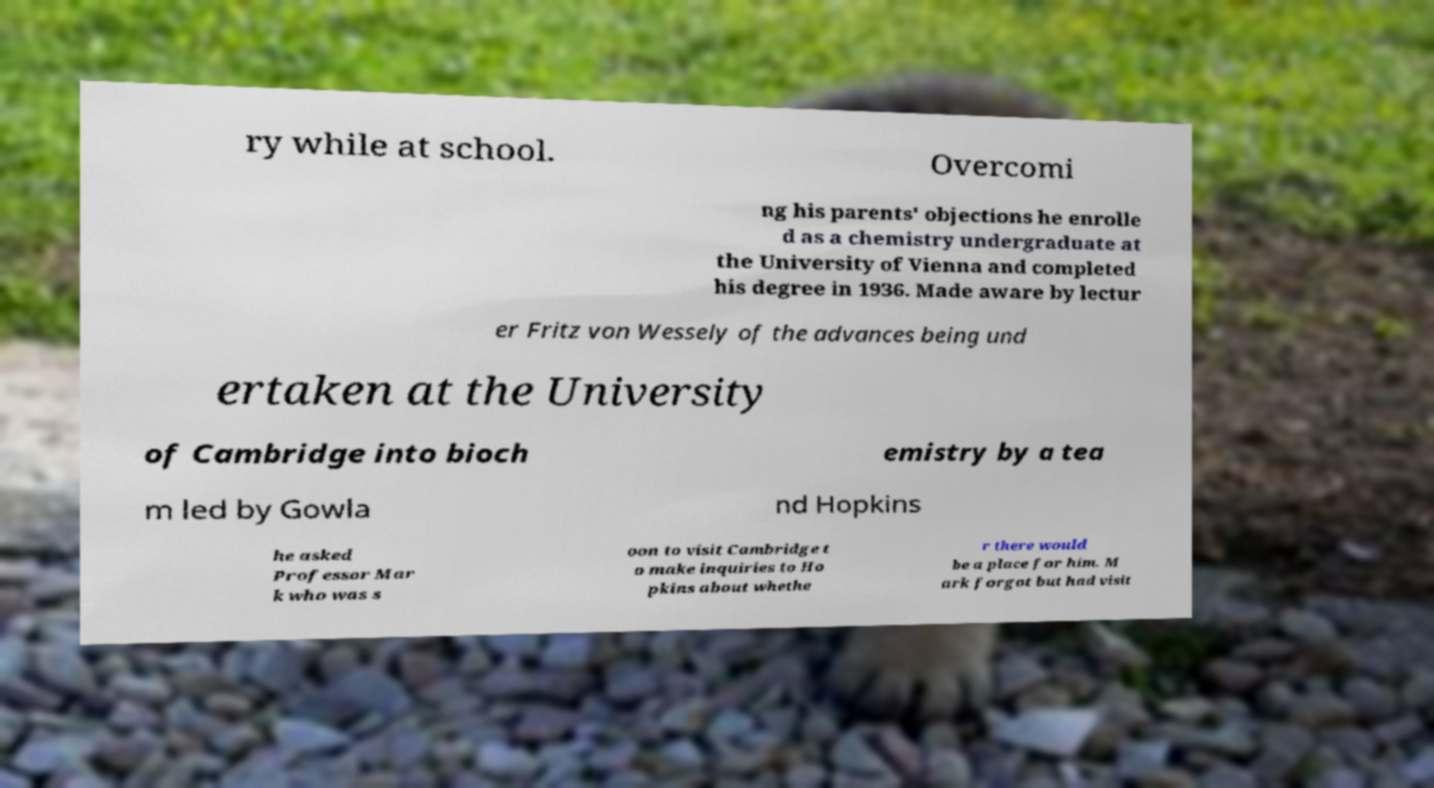I need the written content from this picture converted into text. Can you do that? ry while at school. Overcomi ng his parents' objections he enrolle d as a chemistry undergraduate at the University of Vienna and completed his degree in 1936. Made aware by lectur er Fritz von Wessely of the advances being und ertaken at the University of Cambridge into bioch emistry by a tea m led by Gowla nd Hopkins he asked Professor Mar k who was s oon to visit Cambridge t o make inquiries to Ho pkins about whethe r there would be a place for him. M ark forgot but had visit 